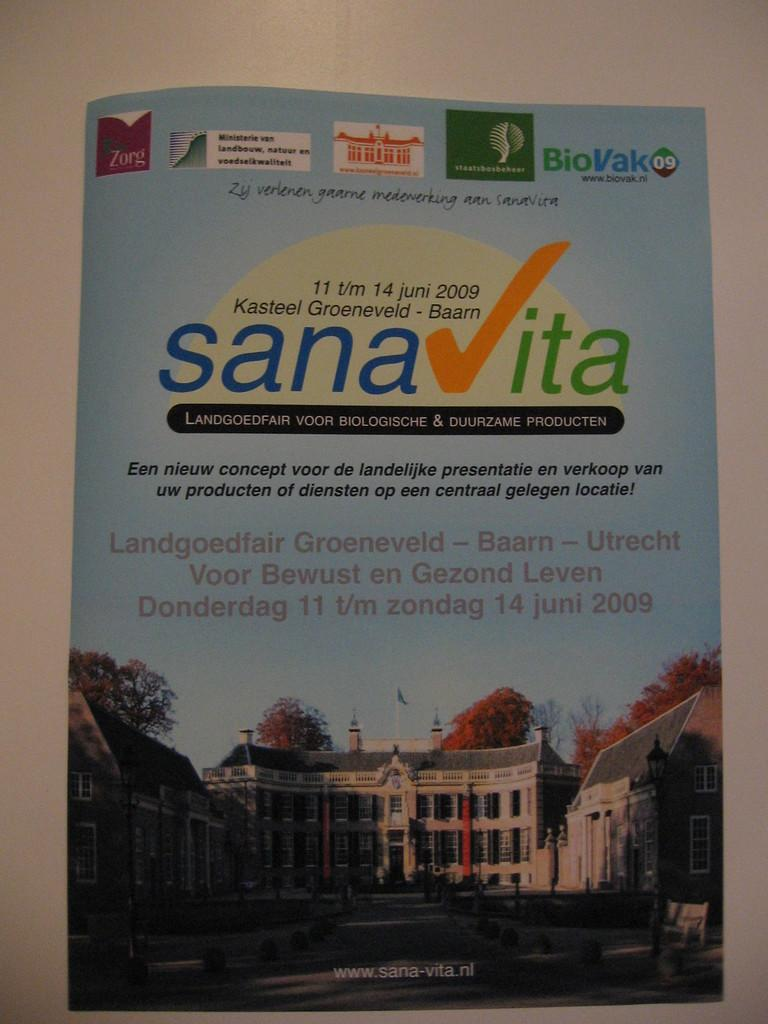<image>
Offer a succinct explanation of the picture presented. Brochure for Sanavita featuring a large building on the front. 